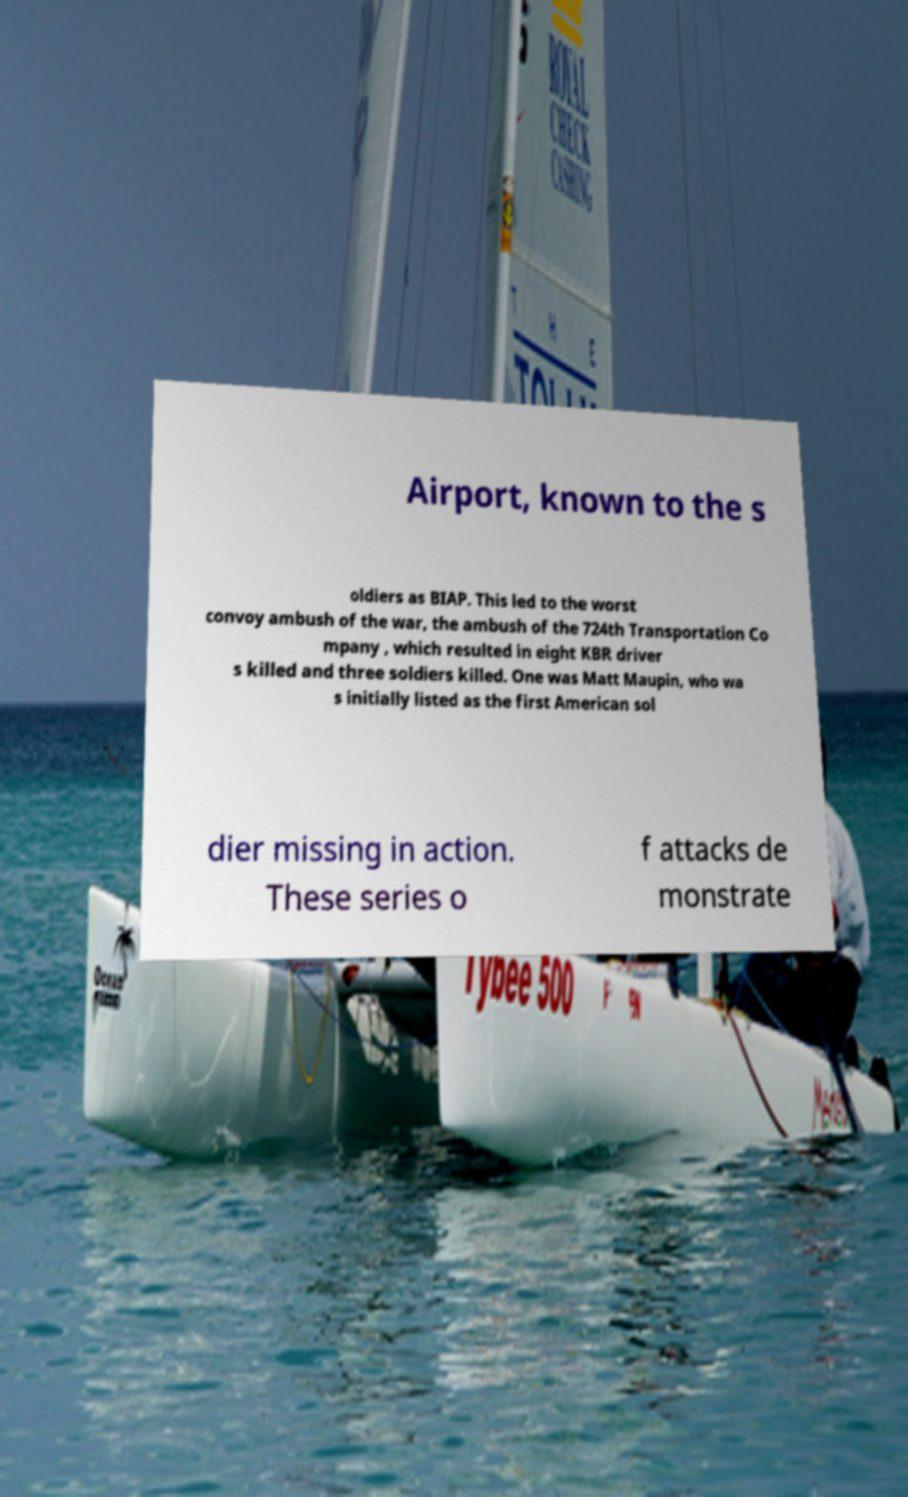Could you extract and type out the text from this image? Airport, known to the s oldiers as BIAP. This led to the worst convoy ambush of the war, the ambush of the 724th Transportation Co mpany , which resulted in eight KBR driver s killed and three soldiers killed. One was Matt Maupin, who wa s initially listed as the first American sol dier missing in action. These series o f attacks de monstrate 